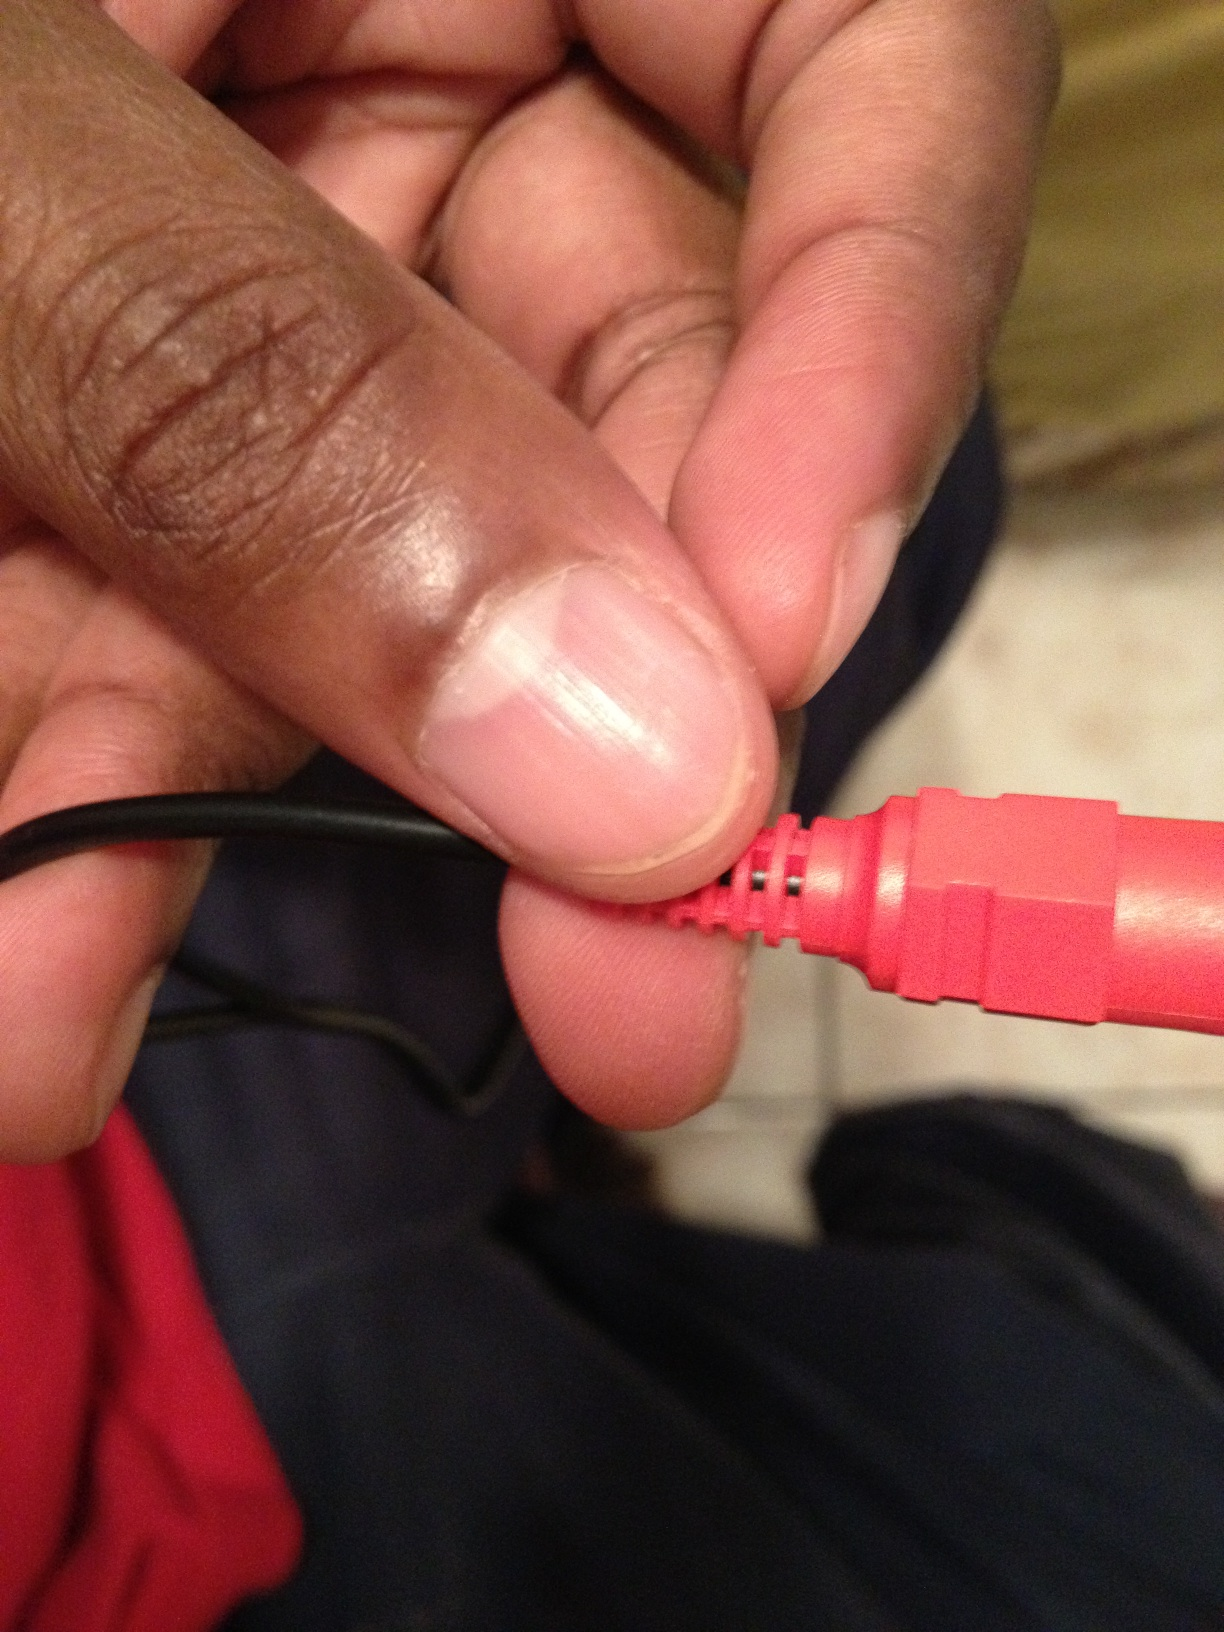In a realistic scenario, what might this connector be used for in a simple household? In a typical household, this connector might be part of an audio system, used to connect speakers to a stereo receiver or an auxiliary cable to play music from a smartphone through a home audio system. How about in a more complex household device? In a more complex household device, this connector could be used in a home automation system. It might connect sensors and control units to a central hub, allowing for integrated management of lighting, security, heating, and other smart home features through a unified interface. 